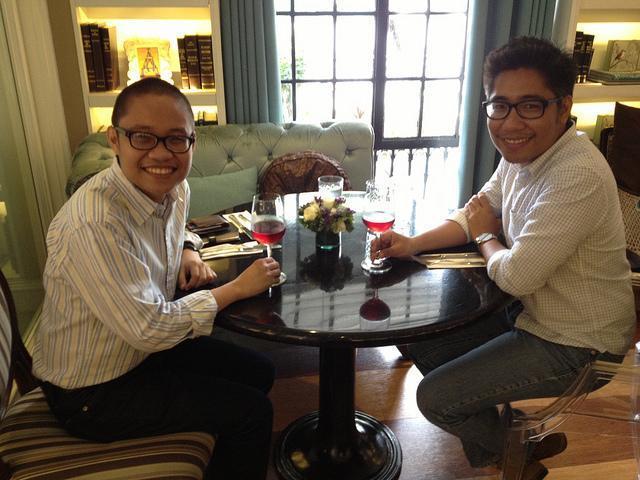How many people are wearing glasses?
Give a very brief answer. 2. How many people are there?
Give a very brief answer. 2. How many chairs are visible?
Give a very brief answer. 2. How many elephants can you see it's trunk?
Give a very brief answer. 0. 